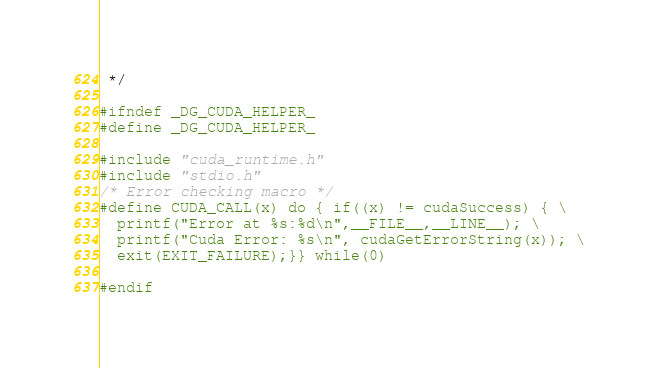<code> <loc_0><loc_0><loc_500><loc_500><_Cuda_> */

#ifndef _DG_CUDA_HELPER_
#define _DG_CUDA_HELPER_

#include "cuda_runtime.h"
#include "stdio.h"
/* Error checking macro */
#define CUDA_CALL(x) do { if((x) != cudaSuccess) { \
  printf("Error at %s:%d\n",__FILE__,__LINE__); \
  printf("Cuda Error: %s\n", cudaGetErrorString(x)); \
  exit(EXIT_FAILURE);}} while(0)

#endif
</code> 